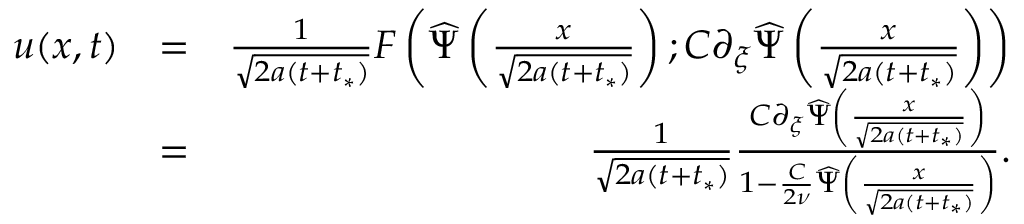<formula> <loc_0><loc_0><loc_500><loc_500>\begin{array} { r l r } { u ( x , t ) } & { = } & { \frac { 1 } { \sqrt { 2 a ( t + t _ { * } ) } } F \left ( \widehat { \Psi } \left ( \frac { x } { \sqrt { 2 a ( t + t _ { * } ) } } \right ) ; C \partial _ { \xi } \widehat { \Psi } \left ( \frac { x } { \sqrt { 2 a ( t + t _ { * } ) } } \right ) \right ) } \\ & { = } & { \frac { 1 } { \sqrt { 2 a ( t + t _ { * } ) } } \frac { C \partial _ { \xi } \widehat { \Psi } \left ( \frac { x } { \sqrt { 2 a ( t + t _ { * } ) } } \right ) } { 1 - \frac { C } { 2 \nu } \widehat { \Psi } \left ( \frac { x } { \sqrt { 2 a ( t + t _ { * } ) } } \right ) } . } \end{array}</formula> 